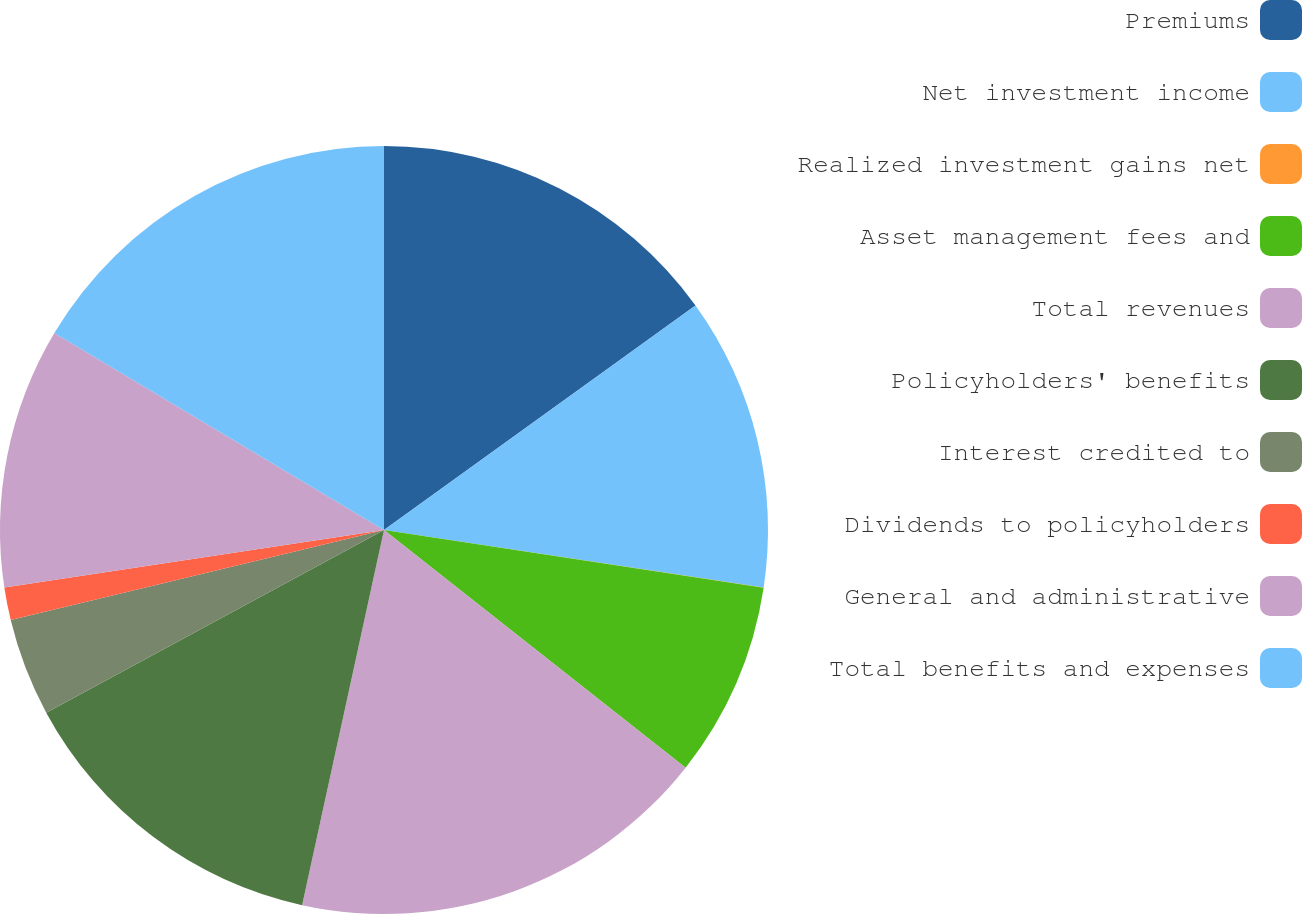<chart> <loc_0><loc_0><loc_500><loc_500><pie_chart><fcel>Premiums<fcel>Net investment income<fcel>Realized investment gains net<fcel>Asset management fees and<fcel>Total revenues<fcel>Policyholders' benefits<fcel>Interest credited to<fcel>Dividends to policyholders<fcel>General and administrative<fcel>Total benefits and expenses<nl><fcel>15.06%<fcel>12.33%<fcel>0.01%<fcel>8.22%<fcel>17.8%<fcel>13.69%<fcel>4.12%<fcel>1.38%<fcel>10.96%<fcel>16.43%<nl></chart> 